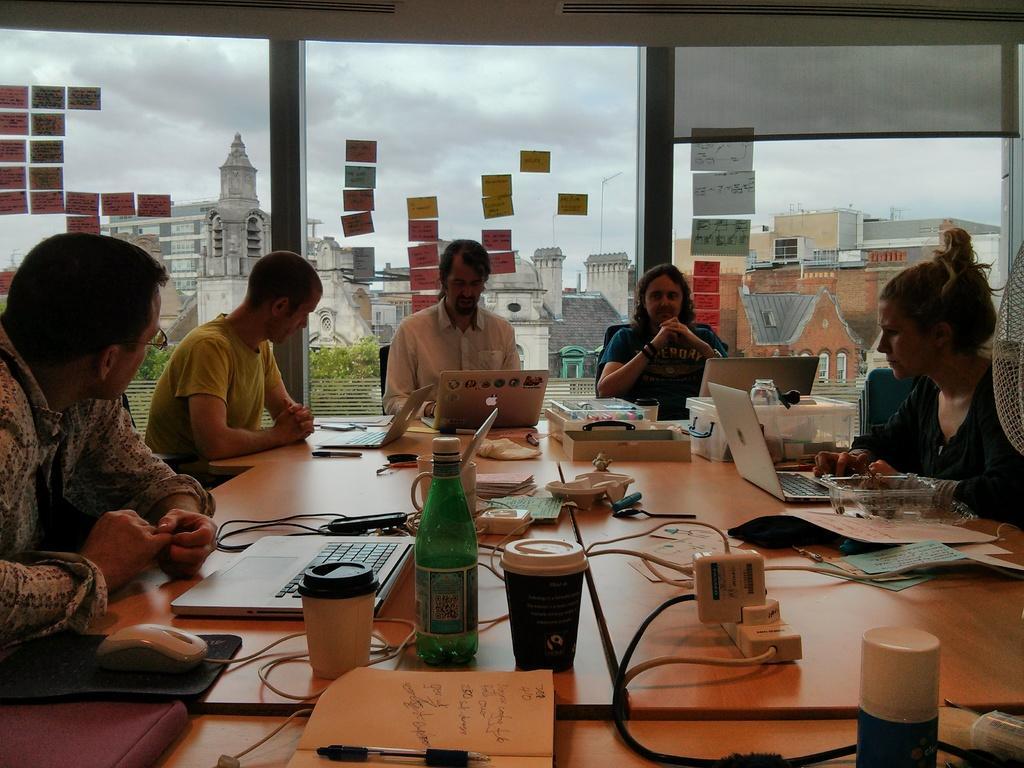In one or two sentences, can you explain what this image depicts? In this image there is a table on the bottom of this image and there are some objects kept on it and there are some laptops kept on this table as we can see in middle of this image. There are some persons sitting on the chairs around to this table. There is a glass door in the background and there are some buildings at top of this image and there is a sky on the top of this image. 